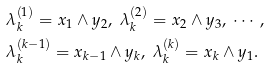<formula> <loc_0><loc_0><loc_500><loc_500>& \lambda _ { k } ^ { ( 1 ) } = x _ { 1 } \wedge y _ { 2 } , \ \lambda _ { k } ^ { ( 2 ) } = x _ { 2 } \wedge y _ { 3 } , \ \cdots , \\ & \lambda _ { k } ^ { ( k - 1 ) } = x _ { k - 1 } \wedge y _ { k } , \ \lambda _ { k } ^ { ( k ) } = x _ { k } \wedge y _ { 1 } .</formula> 